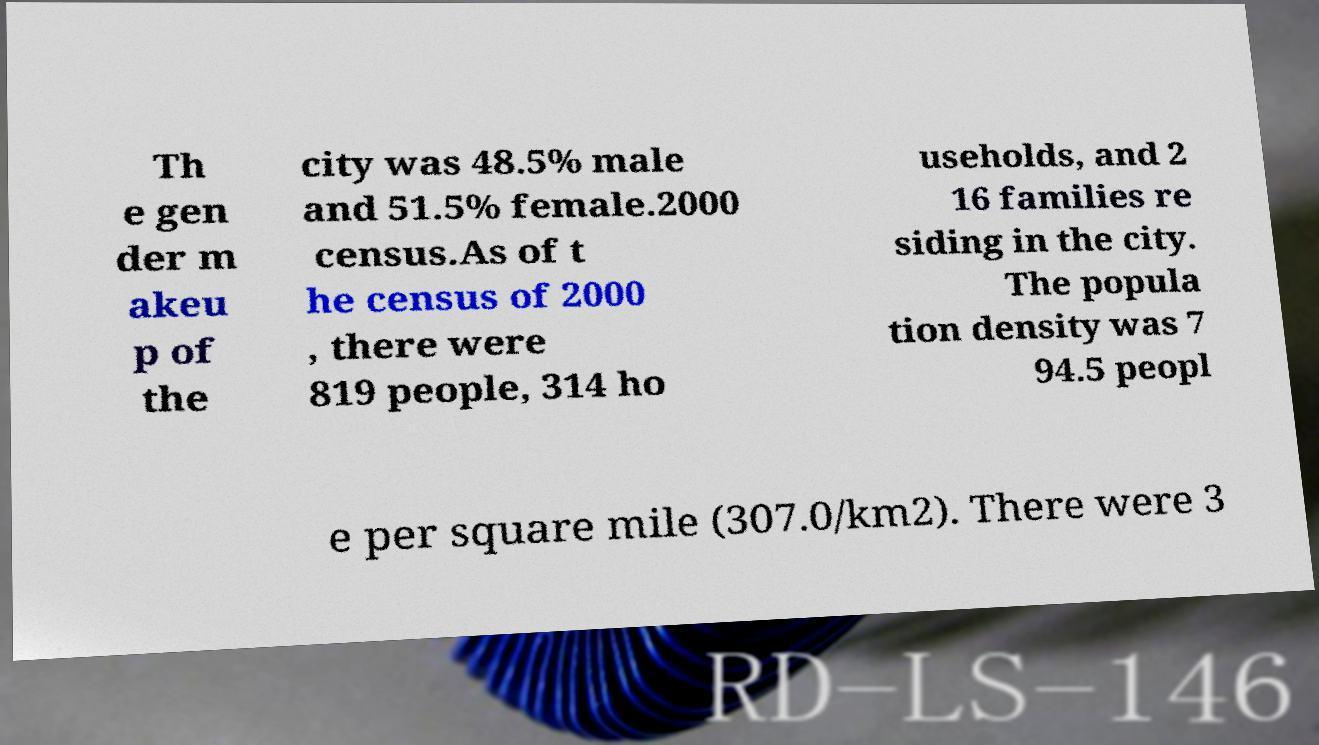There's text embedded in this image that I need extracted. Can you transcribe it verbatim? Th e gen der m akeu p of the city was 48.5% male and 51.5% female.2000 census.As of t he census of 2000 , there were 819 people, 314 ho useholds, and 2 16 families re siding in the city. The popula tion density was 7 94.5 peopl e per square mile (307.0/km2). There were 3 